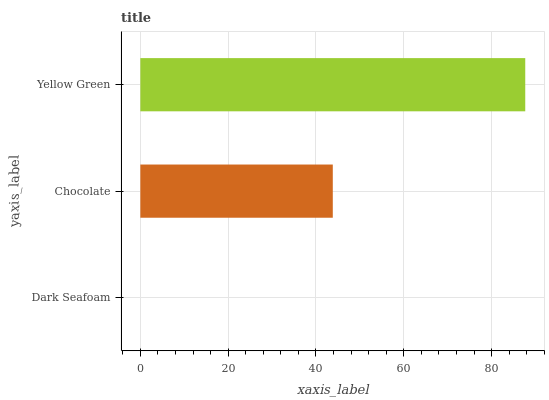Is Dark Seafoam the minimum?
Answer yes or no. Yes. Is Yellow Green the maximum?
Answer yes or no. Yes. Is Chocolate the minimum?
Answer yes or no. No. Is Chocolate the maximum?
Answer yes or no. No. Is Chocolate greater than Dark Seafoam?
Answer yes or no. Yes. Is Dark Seafoam less than Chocolate?
Answer yes or no. Yes. Is Dark Seafoam greater than Chocolate?
Answer yes or no. No. Is Chocolate less than Dark Seafoam?
Answer yes or no. No. Is Chocolate the high median?
Answer yes or no. Yes. Is Chocolate the low median?
Answer yes or no. Yes. Is Yellow Green the high median?
Answer yes or no. No. Is Dark Seafoam the low median?
Answer yes or no. No. 